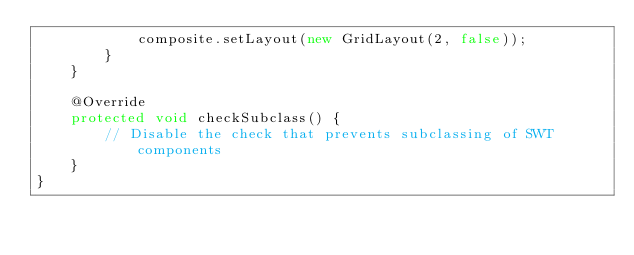<code> <loc_0><loc_0><loc_500><loc_500><_Java_>			composite.setLayout(new GridLayout(2, false));
		}
	}
	
	@Override
	protected void checkSubclass() {
		// Disable the check that prevents subclassing of SWT components
	}
}
</code> 